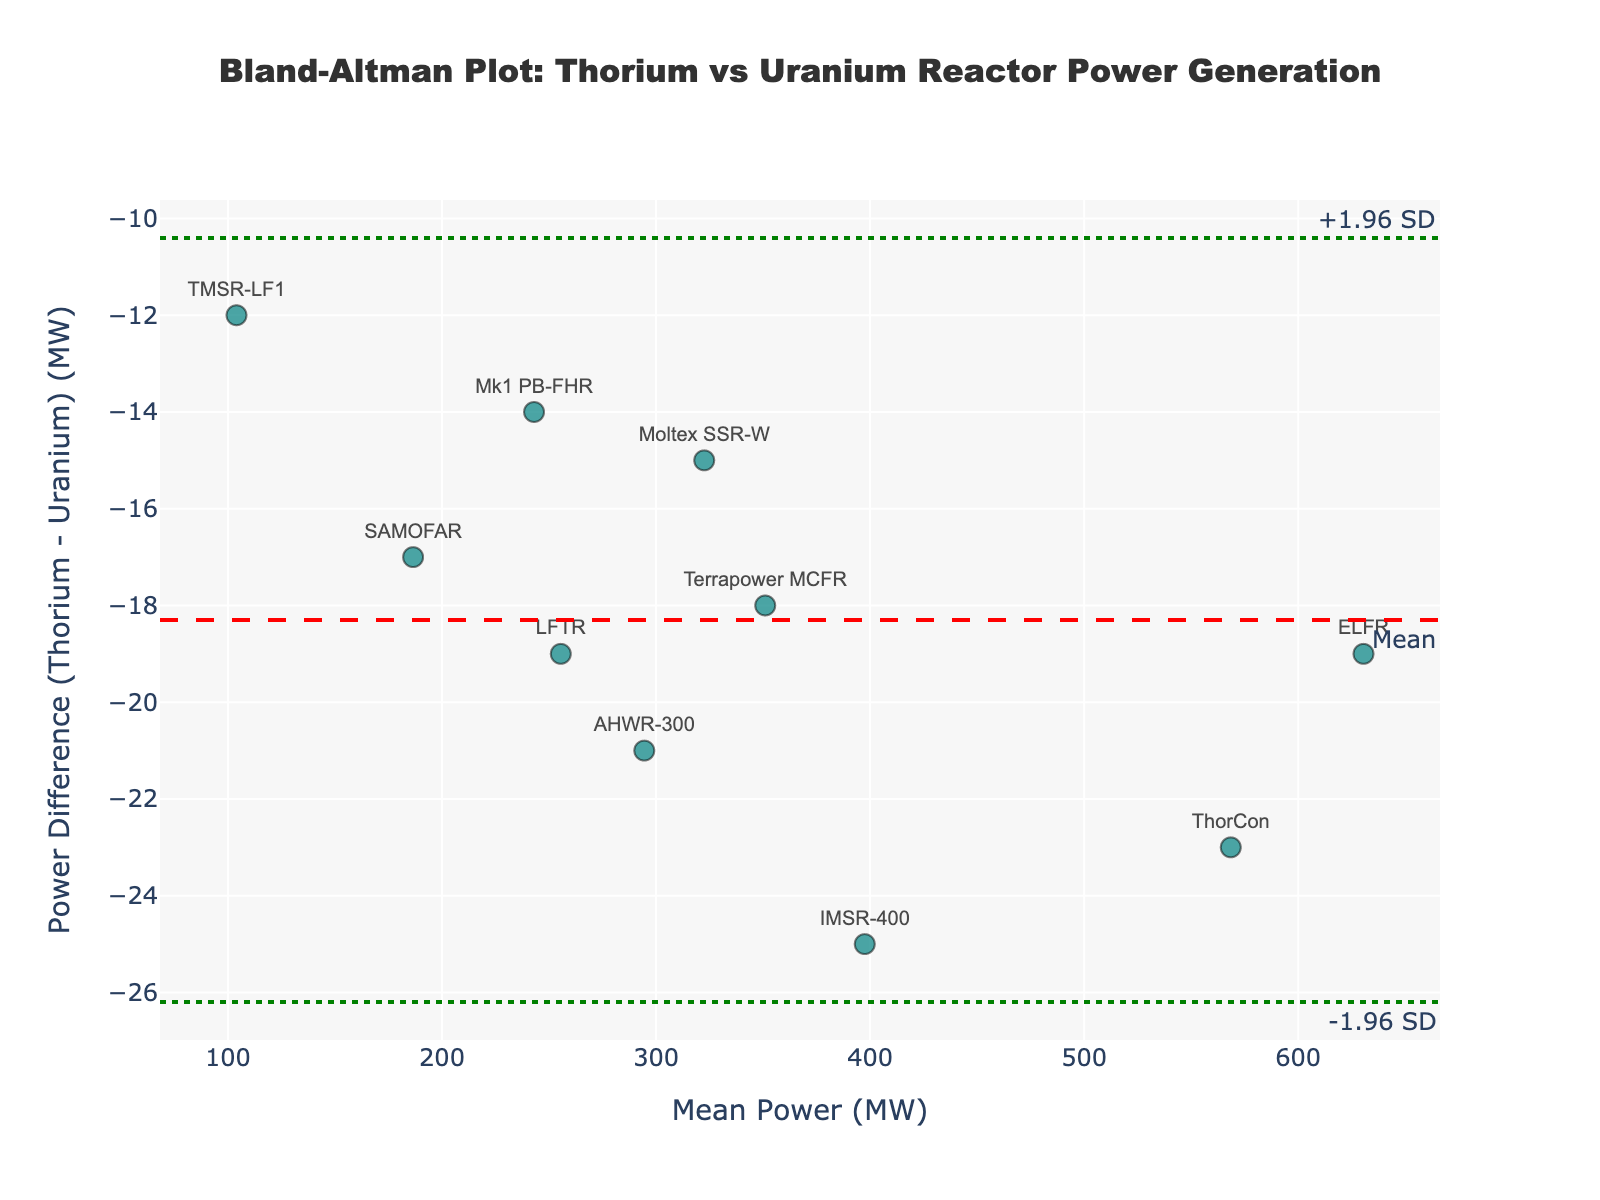What is the title of the figure? The title is located at the top of the figure and is usually the largest text. It reads "Bland-Altman Plot: Thorium vs Uranium Reactor Power Generation".
Answer: Bland-Altman Plot: Thorium vs Uranium Reactor Power Generation How many reactor types are represented in the plot? Each data point represents a reactor type and they are labeled with their names above the markers. Counting these labels reveals there are 10 reactor types.
Answer: 10 What power difference is represented by the mean line? The mean line is annotated with the text "Mean" and its value can be identified by its position on the y-axis. The y-axis annotation and line positioning indicate it represents a power difference of -18.3 MW.
Answer: -18.3 MW How many reactors have power differences outside +/- 1.96 SD? The dot-dashed lines represent +/- 1.96 SD and establish the range of expected differences. By visually inspecting which points are outside these lines, we count zero points outside of this range.
Answer: 0 Which reactor has the largest negative power difference? The data point with the largest negative y-value signifies the largest negative power difference. Inspecting the plot shows "IMSR-400" has the largest negative power difference at -25 MW.
Answer: IMSR-400 What is the range of the mean power values (MW) on the x-axis? The x-axis denotes mean power values. The lowest and highest x-values indicate the range, which spans from about 100 MW to around 630 MW.
Answer: 100 MW to 630 MW Is there a consistent pattern in power differences as the mean power increases? Observing the scatter pattern across the x-axis, no clear increasing or decreasing trend in the power differences is visible, indicating no consistent pattern.
Answer: No consistent pattern What are the limits of agreement (LOA) for the power differences represented on the plot? The LOA are defined by the +/- 1.96 SD lines. The annotations "+1.96 SD" and "-1.96 SD" indicate they are at approximately -12.98 MW and -23.62 MW, respectively.
Answer: -12.98 MW to -23.62 MW What is the power difference for the "ThorCon" reactor? The "ThorCon" reactor is labeled at a specific point on the plot, positioned at -23 MW.
Answer: -23 MW Which reactor types have a power difference of -19 MW? The data points labeled "LFTR" and "ELFR" are positioned at -19 MW on the y-axis, indicating these reactors have a power difference of -19 MW.
Answer: LFTR and ELFR 